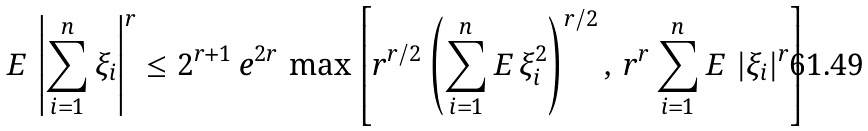Convert formula to latex. <formula><loc_0><loc_0><loc_500><loc_500>{ E \, } \left | \sum _ { i = 1 } ^ { n } \xi _ { i } \right | ^ { r } \leq 2 ^ { r + 1 } \, e ^ { 2 r } \, \max \left [ r ^ { r / 2 } \left ( \sum _ { i = 1 } ^ { n } { E \, } \xi _ { i } ^ { 2 } \right ) ^ { r / 2 } , \, r ^ { r } \sum _ { i = 1 } ^ { n } { E \, } \left | \xi _ { i } \right | ^ { r } \right ]</formula> 